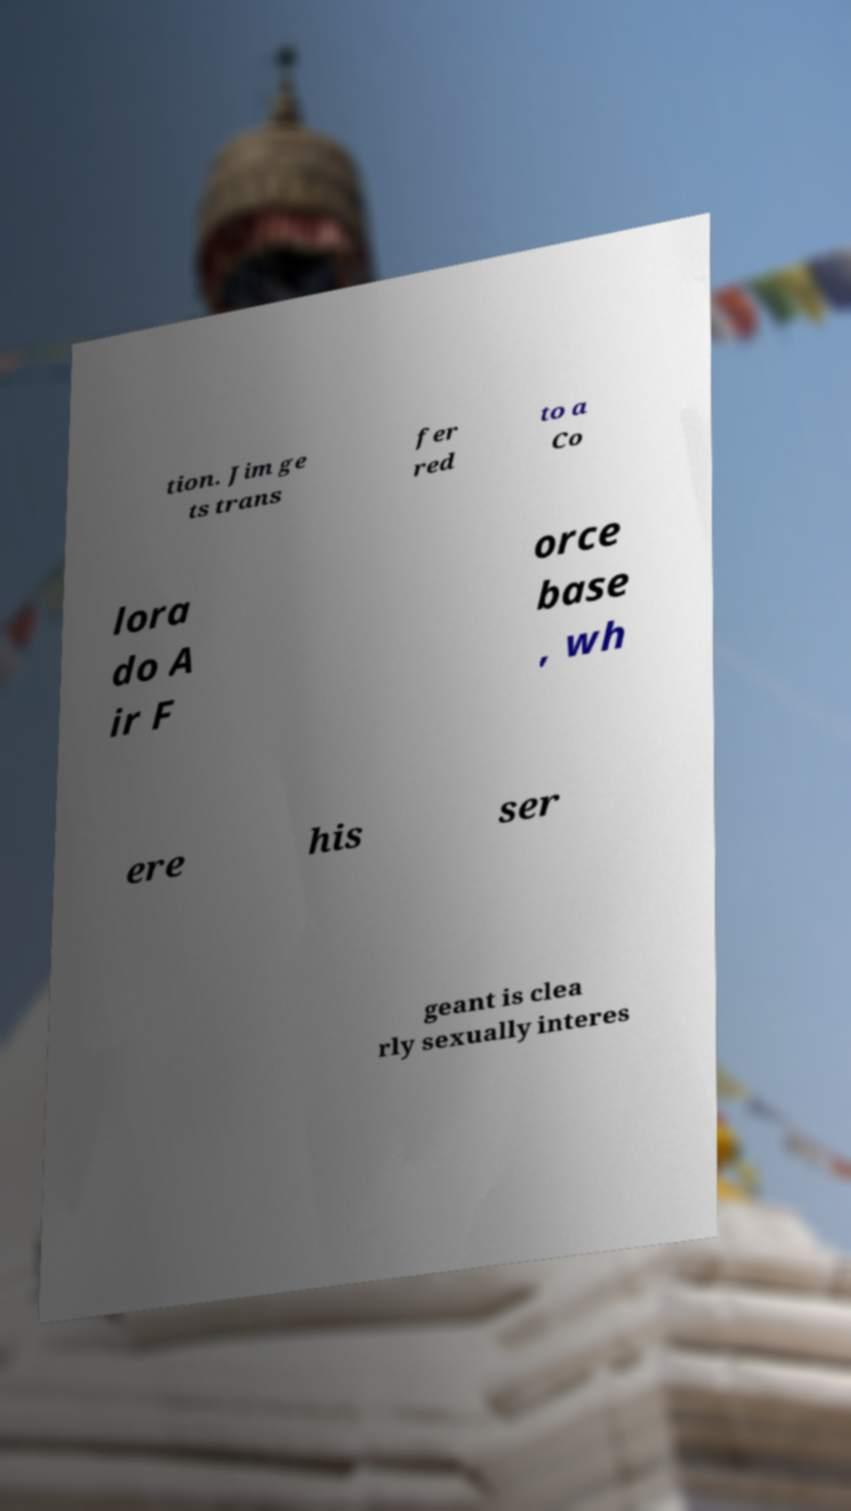Could you extract and type out the text from this image? tion. Jim ge ts trans fer red to a Co lora do A ir F orce base , wh ere his ser geant is clea rly sexually interes 